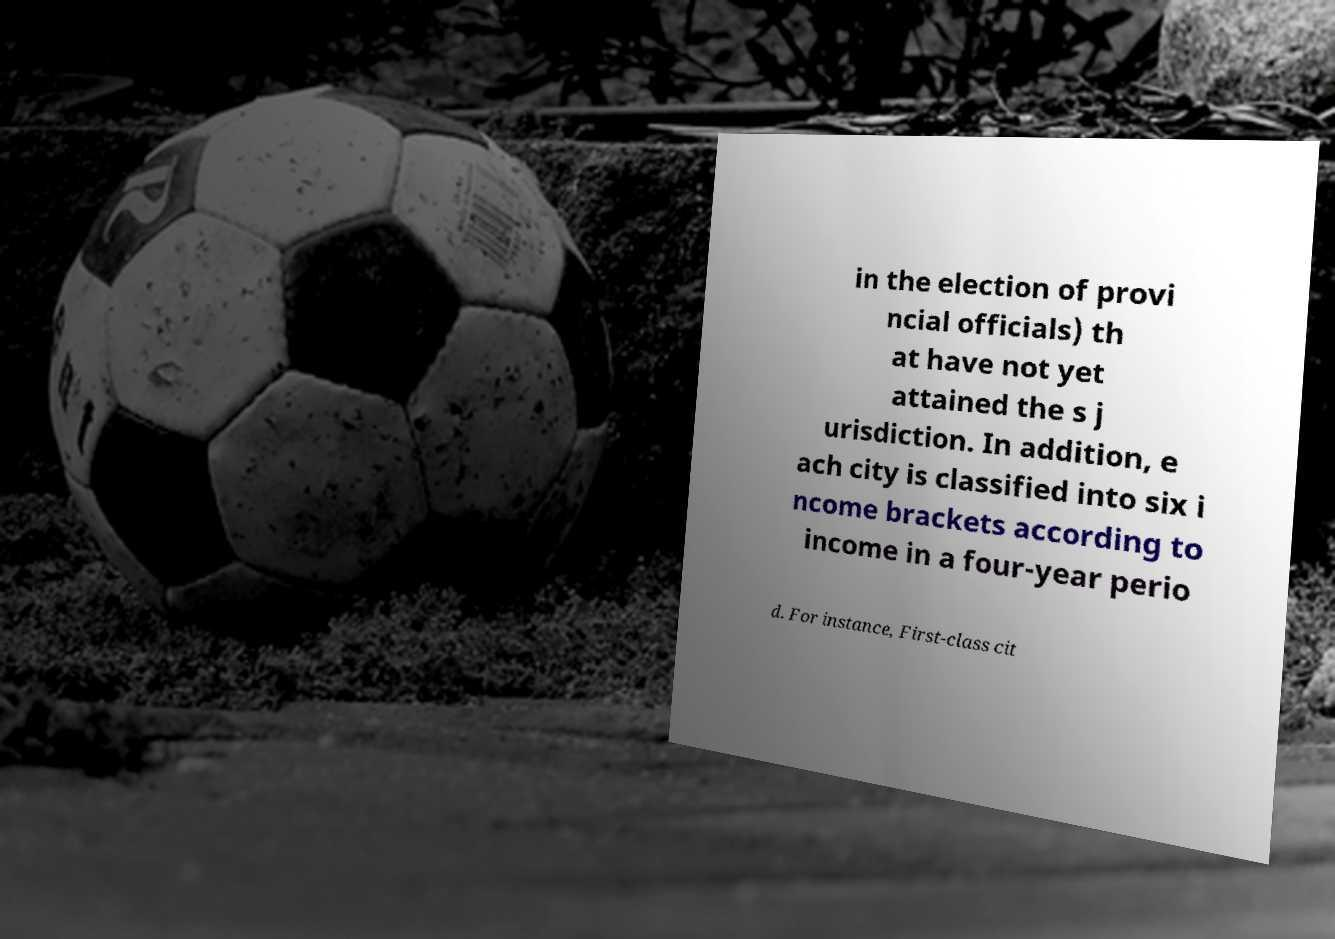I need the written content from this picture converted into text. Can you do that? in the election of provi ncial officials) th at have not yet attained the s j urisdiction. In addition, e ach city is classified into six i ncome brackets according to income in a four-year perio d. For instance, First-class cit 